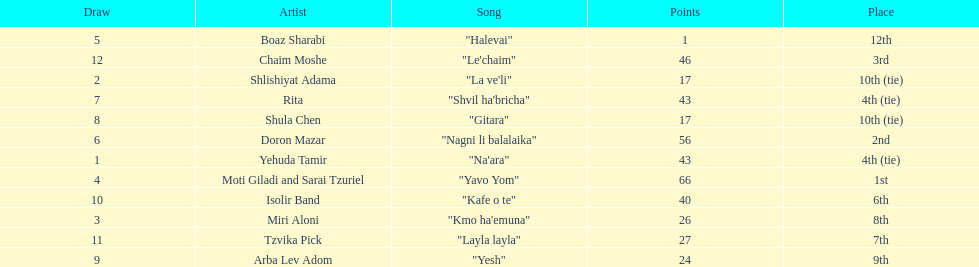What song is listed in the table right before layla layla? "Kafe o te". 